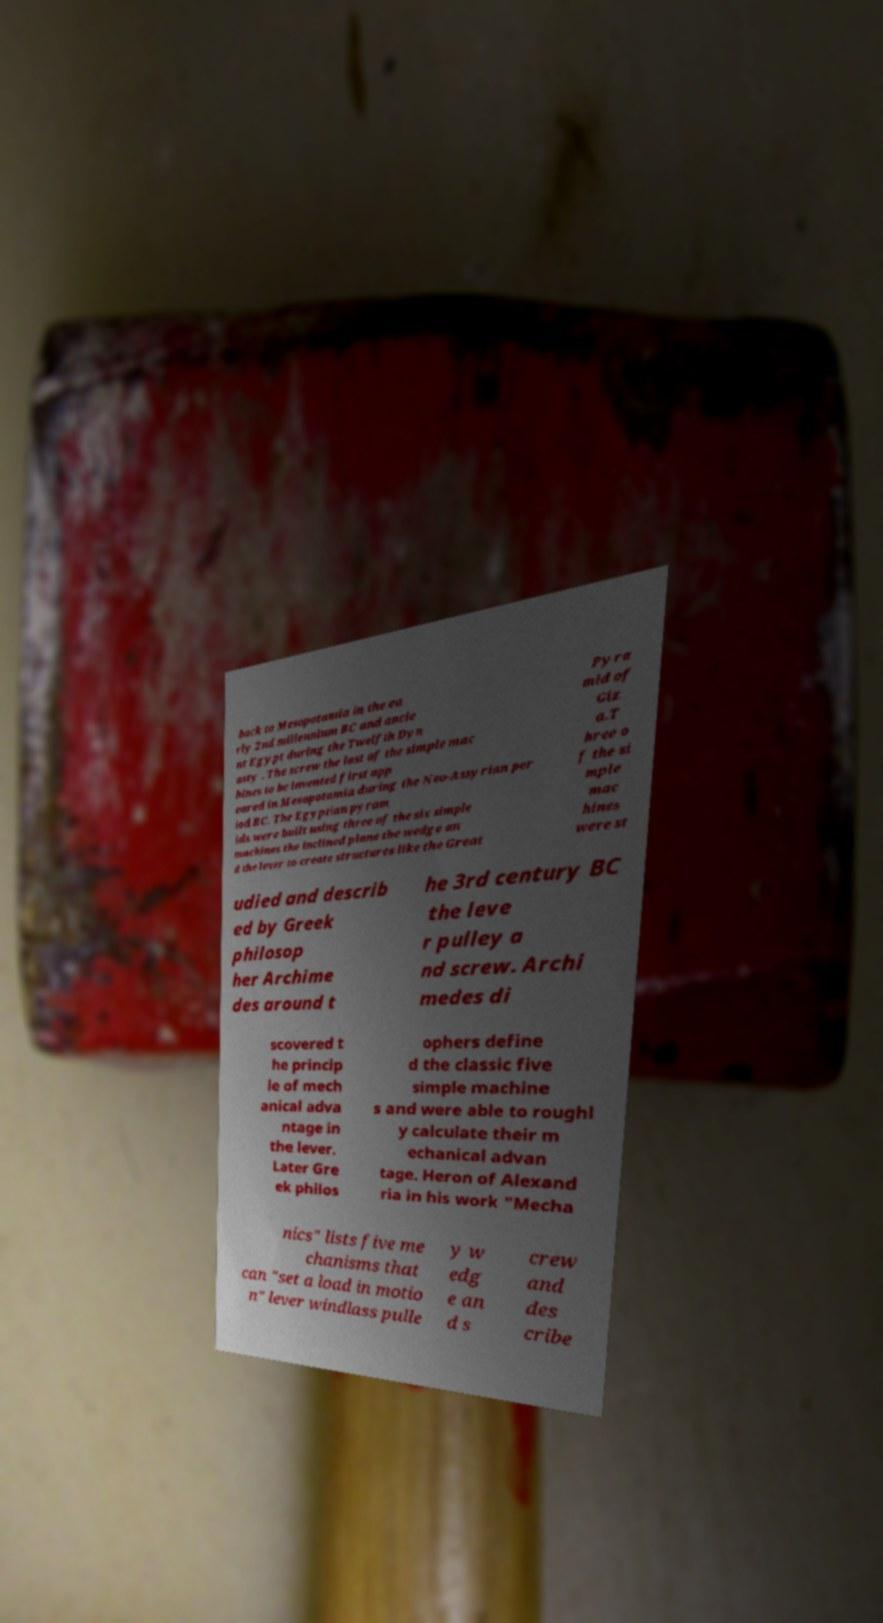For documentation purposes, I need the text within this image transcribed. Could you provide that? back to Mesopotamia in the ea rly 2nd millennium BC and ancie nt Egypt during the Twelfth Dyn asty . The screw the last of the simple mac hines to be invented first app eared in Mesopotamia during the Neo-Assyrian per iod BC. The Egyptian pyram ids were built using three of the six simple machines the inclined plane the wedge an d the lever to create structures like the Great Pyra mid of Giz a.T hree o f the si mple mac hines were st udied and describ ed by Greek philosop her Archime des around t he 3rd century BC the leve r pulley a nd screw. Archi medes di scovered t he princip le of mech anical adva ntage in the lever. Later Gre ek philos ophers define d the classic five simple machine s and were able to roughl y calculate their m echanical advan tage. Heron of Alexand ria in his work "Mecha nics" lists five me chanisms that can "set a load in motio n" lever windlass pulle y w edg e an d s crew and des cribe 